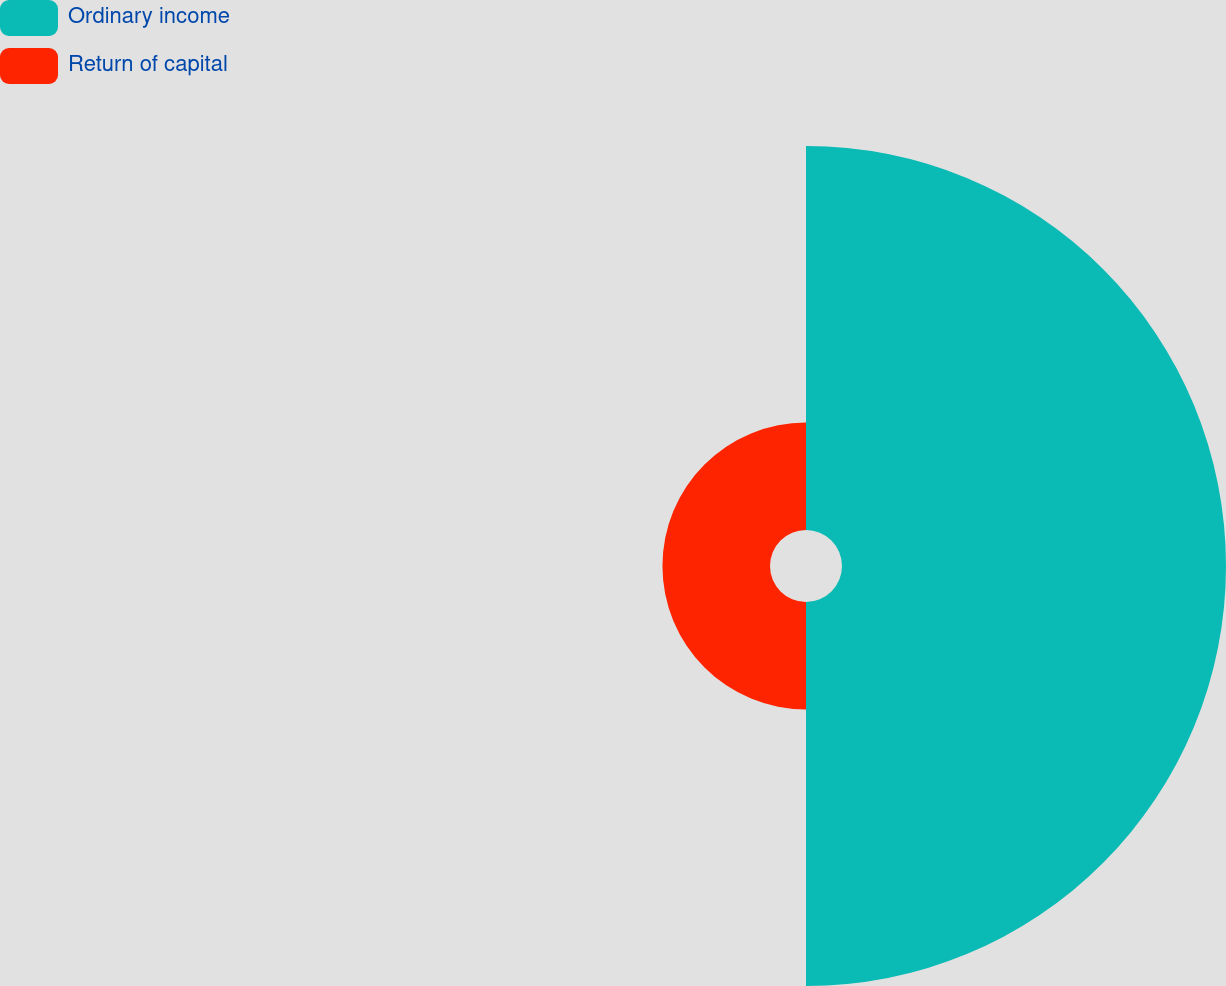Convert chart to OTSL. <chart><loc_0><loc_0><loc_500><loc_500><pie_chart><fcel>Ordinary income<fcel>Return of capital<nl><fcel>78.12%<fcel>21.88%<nl></chart> 